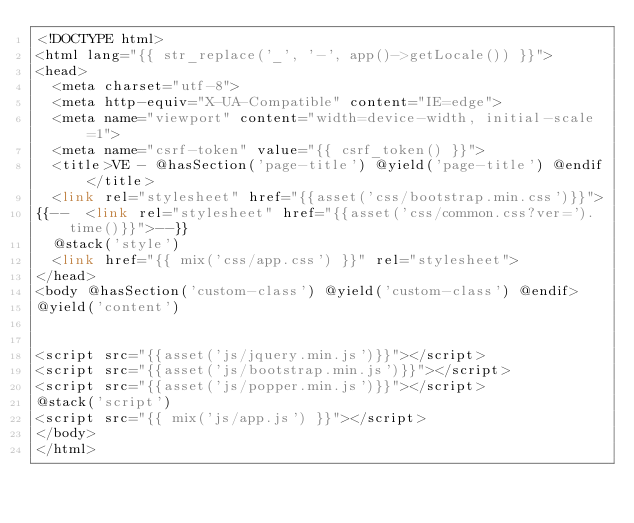<code> <loc_0><loc_0><loc_500><loc_500><_PHP_><!DOCTYPE html>
<html lang="{{ str_replace('_', '-', app()->getLocale()) }}">
<head>
  <meta charset="utf-8">
  <meta http-equiv="X-UA-Compatible" content="IE=edge">
  <meta name="viewport" content="width=device-width, initial-scale=1">
  <meta name="csrf-token" value="{{ csrf_token() }}">
  <title>VE - @hasSection('page-title') @yield('page-title') @endif</title>
  <link rel="stylesheet" href="{{asset('css/bootstrap.min.css')}}">
{{--  <link rel="stylesheet" href="{{asset('css/common.css?ver=').time()}}">--}}
  @stack('style')
  <link href="{{ mix('css/app.css') }}" rel="stylesheet">
</head>
<body @hasSection('custom-class') @yield('custom-class') @endif>
@yield('content')


<script src="{{asset('js/jquery.min.js')}}"></script>
<script src="{{asset('js/bootstrap.min.js')}}"></script>
<script src="{{asset('js/popper.min.js')}}"></script>
@stack('script')
<script src="{{ mix('js/app.js') }}"></script>
</body>
</html>
</code> 